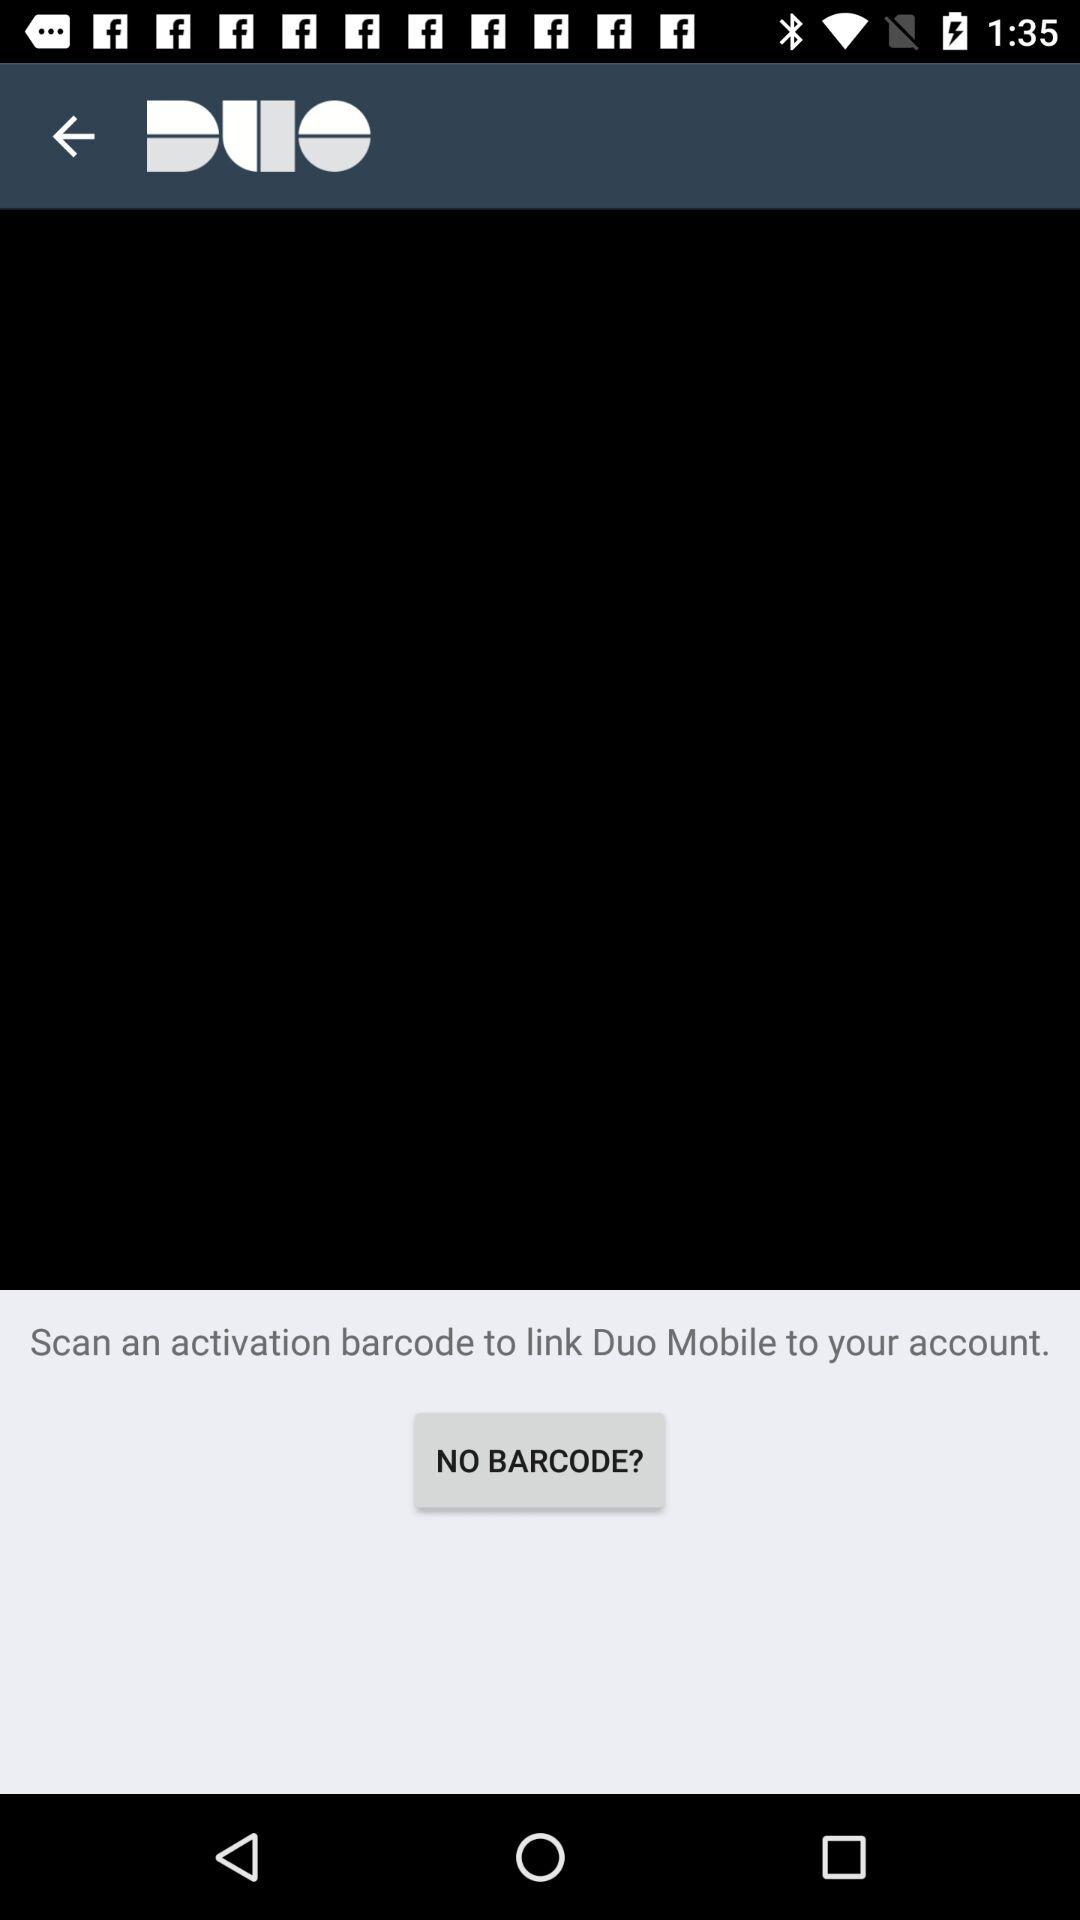What should I do to link "Duo Mobile" to my account? You should scan an activation barcode. 